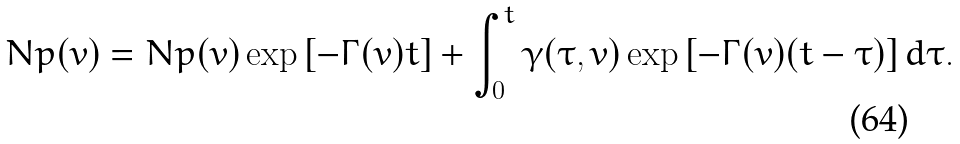<formula> <loc_0><loc_0><loc_500><loc_500>N p ( v ) = N p ( v ) \exp \left [ - \Gamma ( v ) t \right ] + \int _ { 0 } ^ { t } \gamma ( \tau , v ) \exp \left [ - \Gamma ( v ) ( t - \tau ) \right ] d \tau .</formula> 